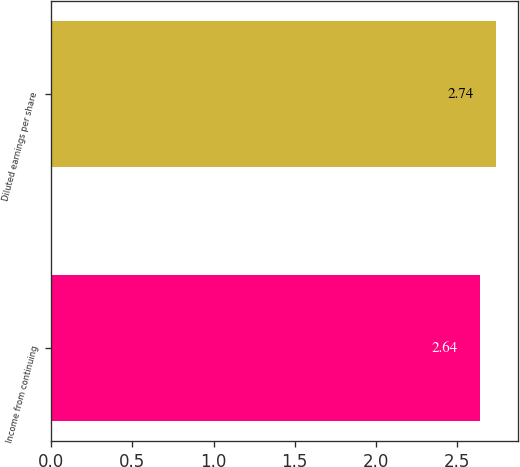Convert chart to OTSL. <chart><loc_0><loc_0><loc_500><loc_500><bar_chart><fcel>Income from continuing<fcel>Diluted earnings per share<nl><fcel>2.64<fcel>2.74<nl></chart> 